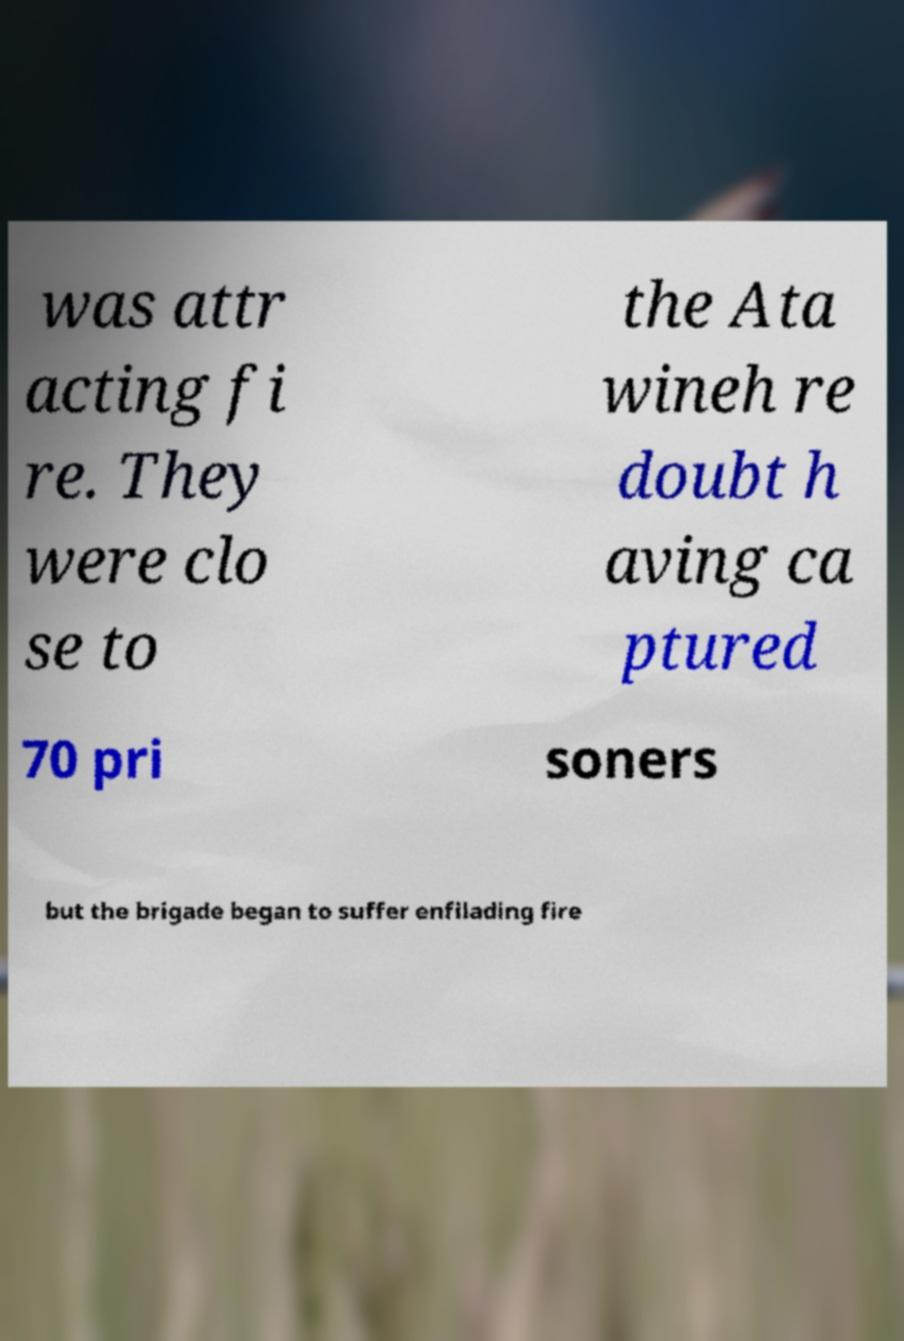Can you accurately transcribe the text from the provided image for me? was attr acting fi re. They were clo se to the Ata wineh re doubt h aving ca ptured 70 pri soners but the brigade began to suffer enfilading fire 